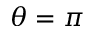<formula> <loc_0><loc_0><loc_500><loc_500>\theta = \pi</formula> 